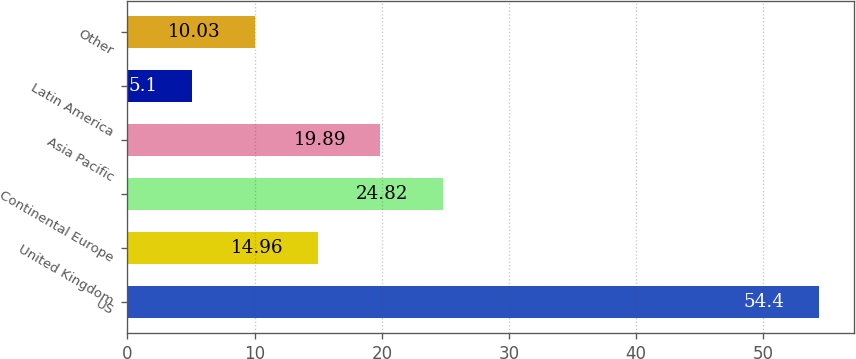Convert chart. <chart><loc_0><loc_0><loc_500><loc_500><bar_chart><fcel>US<fcel>United Kingdom<fcel>Continental Europe<fcel>Asia Pacific<fcel>Latin America<fcel>Other<nl><fcel>54.4<fcel>14.96<fcel>24.82<fcel>19.89<fcel>5.1<fcel>10.03<nl></chart> 